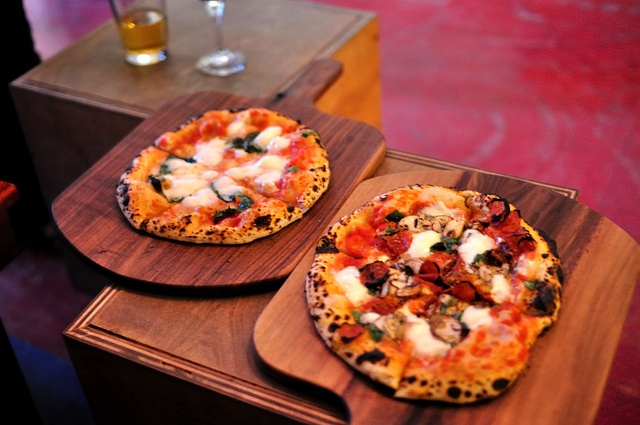Describe the objects in this image and their specific colors. I can see dining table in black, brown, maroon, and red tones, pizza in black, red, orange, brown, and maroon tones, dining table in black, gray, and brown tones, pizza in black, red, orange, tan, and lightgray tones, and cup in black, brown, gray, and maroon tones in this image. 